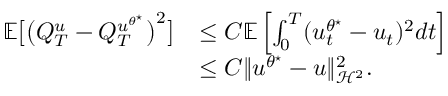<formula> <loc_0><loc_0><loc_500><loc_500>\begin{array} { r l } { \mathbb { E } \left [ \left ( Q _ { T } ^ { u } - Q _ { T } ^ { u ^ { \theta ^ { ^ { * } } } } \right ) ^ { 2 } \right ] } & { \leq C \mathbb { E } \left [ \int _ { 0 } ^ { T } ( u _ { t } ^ { \theta ^ { ^ { * } } } - u _ { t } ) ^ { 2 } d t \right ] } \\ & { \leq C \| u ^ { \theta ^ { ^ { * } } } - u \| _ { \mathcal { H } ^ { 2 } } ^ { 2 } . } \end{array}</formula> 